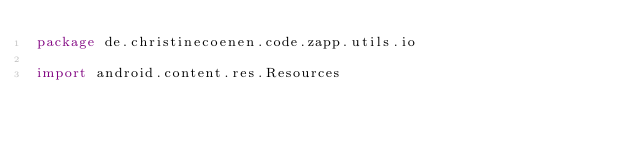Convert code to text. <code><loc_0><loc_0><loc_500><loc_500><_Kotlin_>package de.christinecoenen.code.zapp.utils.io

import android.content.res.Resources</code> 